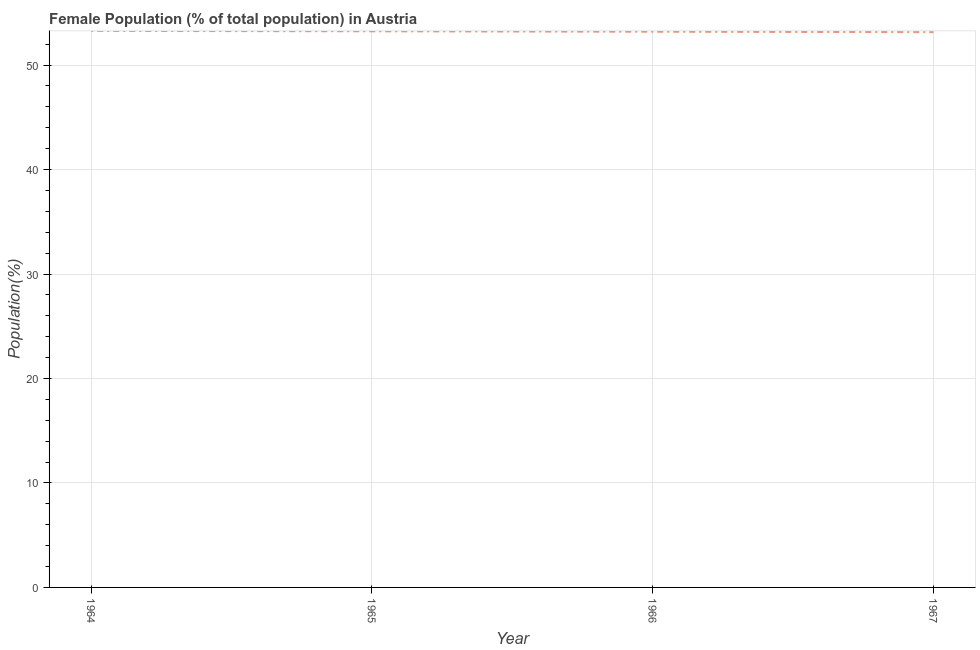What is the female population in 1966?
Offer a very short reply. 53.19. Across all years, what is the maximum female population?
Provide a short and direct response. 53.27. Across all years, what is the minimum female population?
Keep it short and to the point. 53.15. In which year was the female population maximum?
Your answer should be compact. 1964. In which year was the female population minimum?
Your answer should be compact. 1967. What is the sum of the female population?
Offer a terse response. 212.84. What is the difference between the female population in 1964 and 1965?
Make the answer very short. 0.04. What is the average female population per year?
Ensure brevity in your answer.  53.21. What is the median female population?
Offer a terse response. 53.21. In how many years, is the female population greater than 20 %?
Your response must be concise. 4. What is the ratio of the female population in 1966 to that in 1967?
Your response must be concise. 1. Is the female population in 1964 less than that in 1967?
Your answer should be compact. No. Is the difference between the female population in 1965 and 1966 greater than the difference between any two years?
Provide a succinct answer. No. What is the difference between the highest and the second highest female population?
Make the answer very short. 0.04. Is the sum of the female population in 1964 and 1967 greater than the maximum female population across all years?
Ensure brevity in your answer.  Yes. What is the difference between the highest and the lowest female population?
Your response must be concise. 0.12. Does the female population monotonically increase over the years?
Make the answer very short. No. Are the values on the major ticks of Y-axis written in scientific E-notation?
Your response must be concise. No. Does the graph contain grids?
Ensure brevity in your answer.  Yes. What is the title of the graph?
Ensure brevity in your answer.  Female Population (% of total population) in Austria. What is the label or title of the X-axis?
Offer a very short reply. Year. What is the label or title of the Y-axis?
Keep it short and to the point. Population(%). What is the Population(%) in 1964?
Your answer should be very brief. 53.27. What is the Population(%) of 1965?
Your response must be concise. 53.23. What is the Population(%) of 1966?
Your answer should be compact. 53.19. What is the Population(%) of 1967?
Your answer should be compact. 53.15. What is the difference between the Population(%) in 1964 and 1965?
Ensure brevity in your answer.  0.04. What is the difference between the Population(%) in 1964 and 1966?
Make the answer very short. 0.08. What is the difference between the Population(%) in 1964 and 1967?
Offer a very short reply. 0.12. What is the difference between the Population(%) in 1965 and 1966?
Keep it short and to the point. 0.04. What is the difference between the Population(%) in 1965 and 1967?
Give a very brief answer. 0.08. What is the difference between the Population(%) in 1966 and 1967?
Give a very brief answer. 0.04. What is the ratio of the Population(%) in 1964 to that in 1965?
Ensure brevity in your answer.  1. What is the ratio of the Population(%) in 1964 to that in 1966?
Your answer should be very brief. 1. What is the ratio of the Population(%) in 1965 to that in 1966?
Offer a very short reply. 1. 